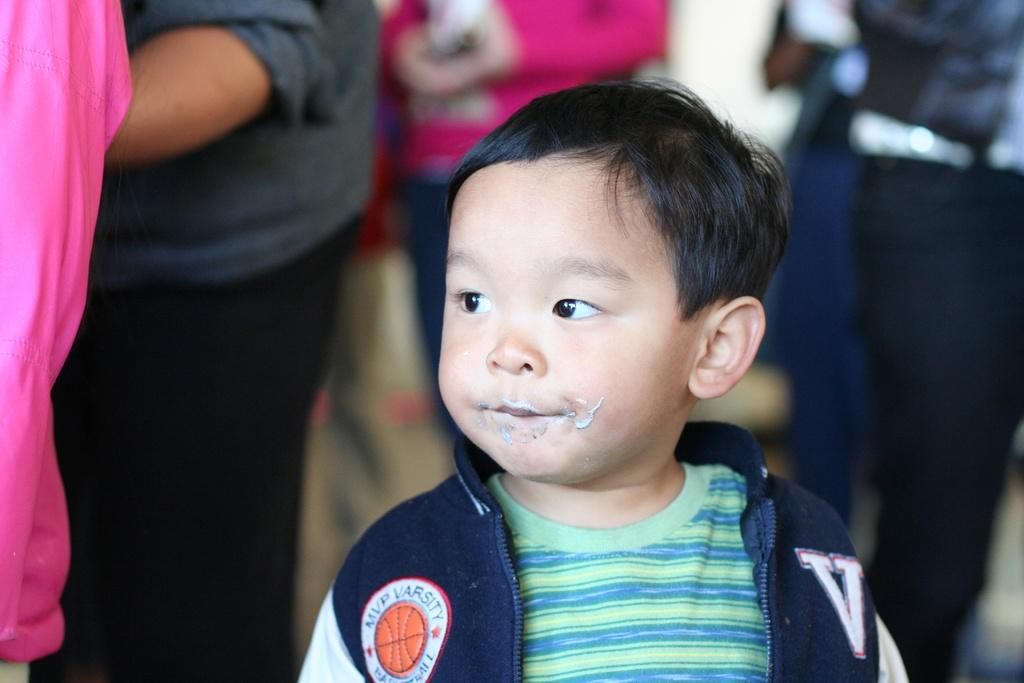<image>
Create a compact narrative representing the image presented. A little asian boy standing wearing a jacket with a V on it. 